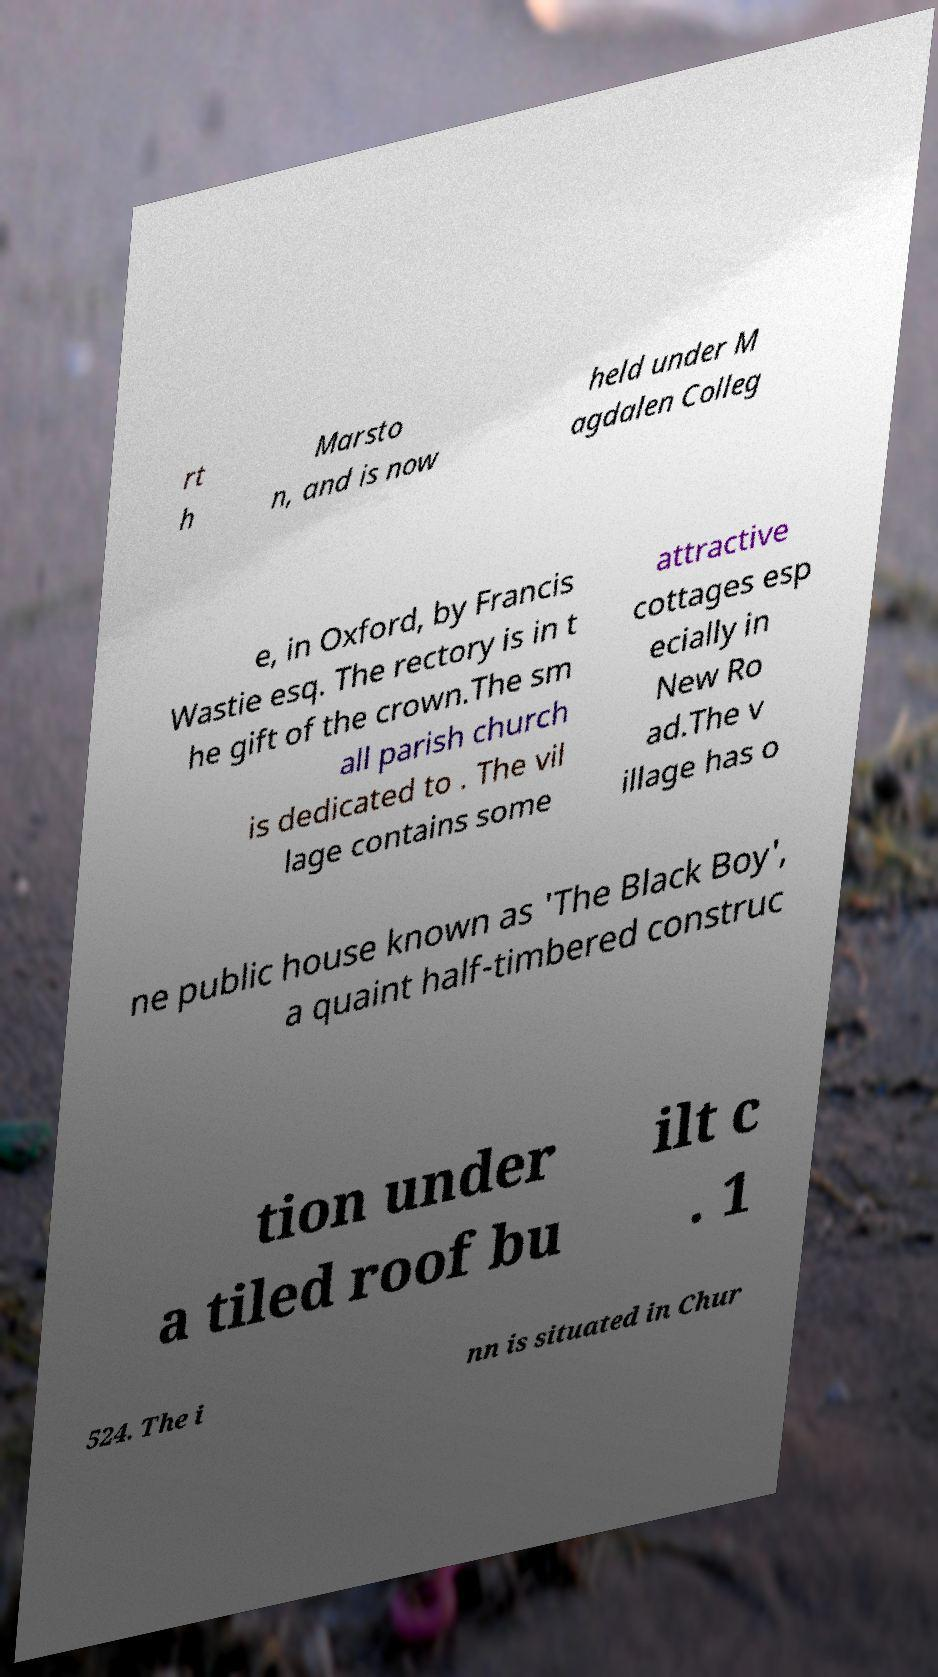There's text embedded in this image that I need extracted. Can you transcribe it verbatim? rt h Marsto n, and is now held under M agdalen Colleg e, in Oxford, by Francis Wastie esq. The rectory is in t he gift of the crown.The sm all parish church is dedicated to . The vil lage contains some attractive cottages esp ecially in New Ro ad.The v illage has o ne public house known as 'The Black Boy', a quaint half-timbered construc tion under a tiled roof bu ilt c . 1 524. The i nn is situated in Chur 